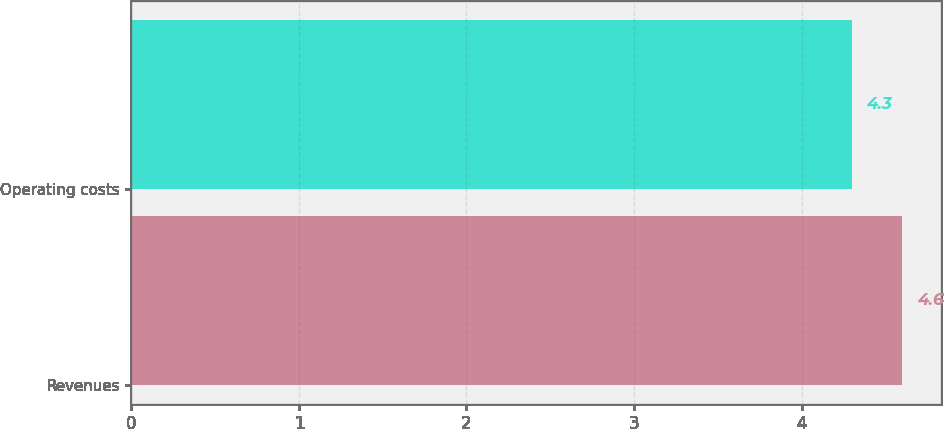Convert chart to OTSL. <chart><loc_0><loc_0><loc_500><loc_500><bar_chart><fcel>Revenues<fcel>Operating costs<nl><fcel>4.6<fcel>4.3<nl></chart> 